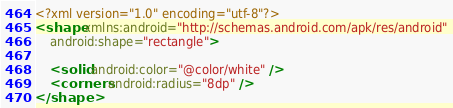<code> <loc_0><loc_0><loc_500><loc_500><_XML_><?xml version="1.0" encoding="utf-8"?>
<shape xmlns:android="http://schemas.android.com/apk/res/android"
    android:shape="rectangle">

    <solid android:color="@color/white" />
    <corners android:radius="8dp" />
</shape></code> 